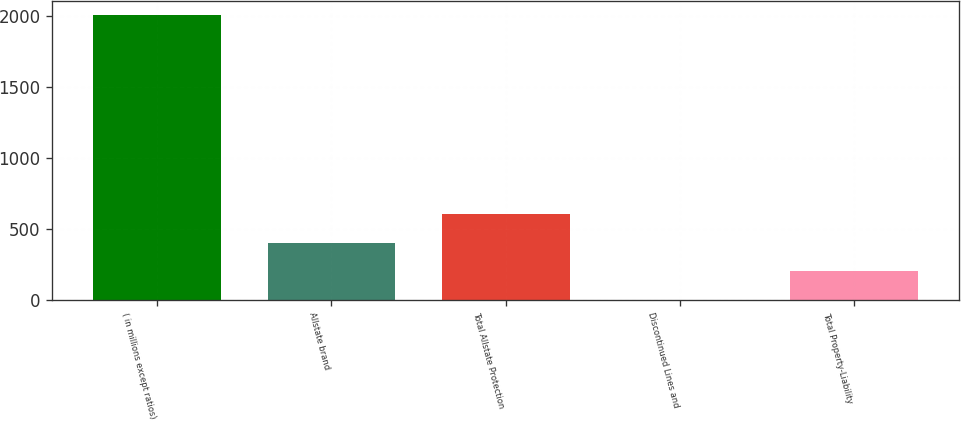Convert chart. <chart><loc_0><loc_0><loc_500><loc_500><bar_chart><fcel>( in millions except ratios)<fcel>Allstate brand<fcel>Total Allstate Protection<fcel>Discontinued Lines and<fcel>Total Property-Liability<nl><fcel>2009<fcel>401.88<fcel>602.77<fcel>0.1<fcel>200.99<nl></chart> 